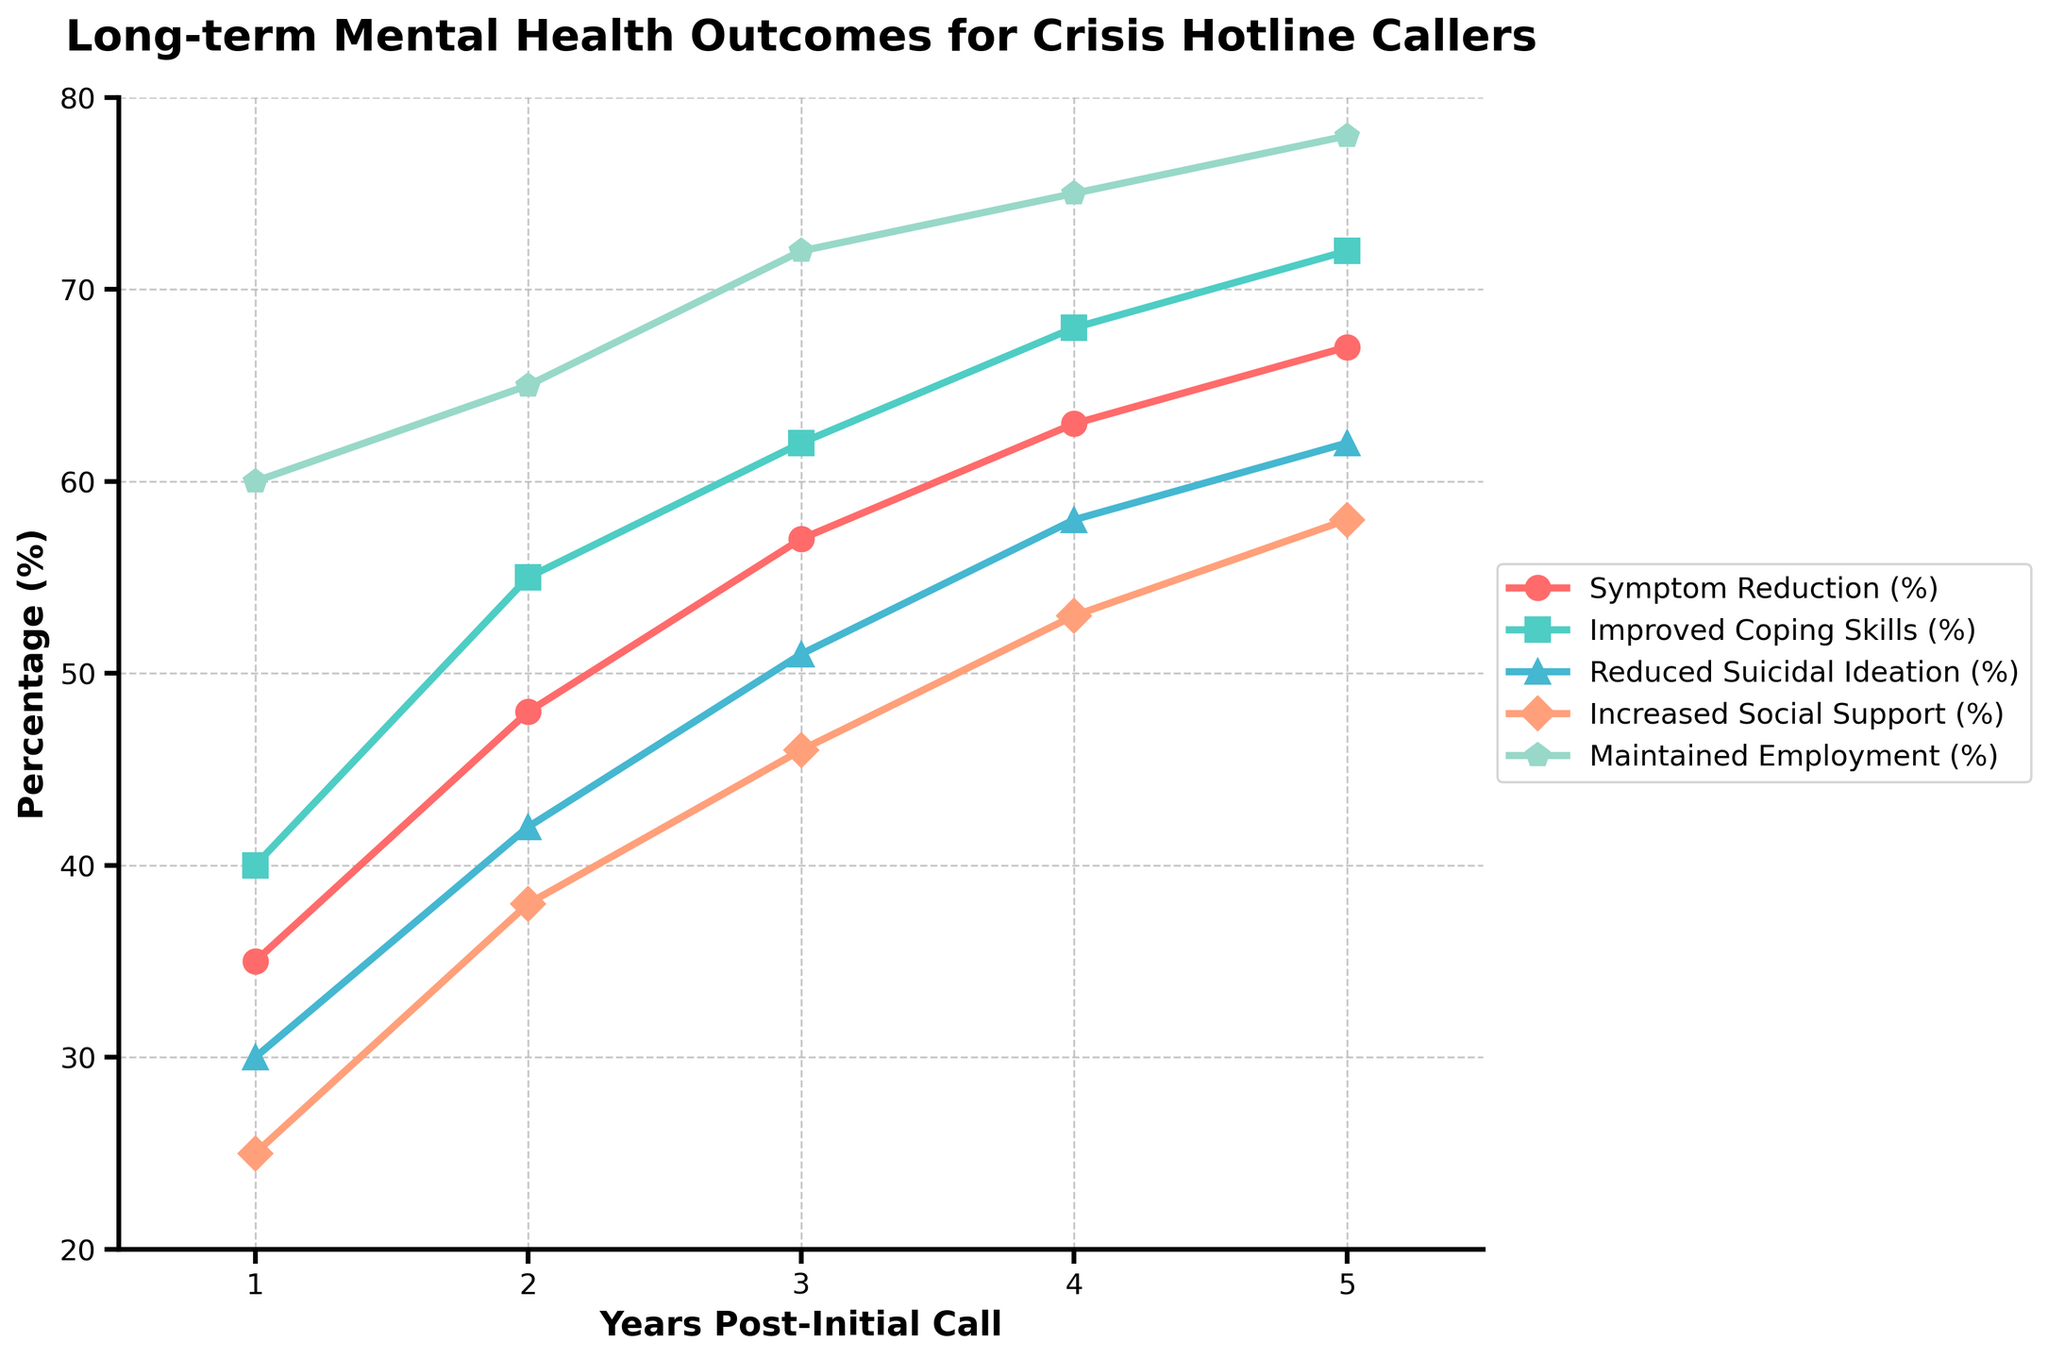What's the overall trend in symptom reduction over the 5 years? Look at the line representing symptom reduction over the 5-year span. It starts at 35% in year 1 and steadily increases each year, reaching 67% in year 5. The overall trend is clearly upward.
Answer: Upward Which metric shows the greatest percentage improvement from year 1 to year 5? Calculate the difference between year 1 and year 5 for each metric. Symptom Reduction: 67 - 35 = 32, Improved Coping Skills: 72 - 40 = 32, Reduced Suicidal Ideation: 62 - 30 = 32, Increased Social Support: 58 - 25 = 33, Maintained Employment: 78 - 60 = 18. Increased Social Support shows the greatest improvement.
Answer: Increased Social Support In year 3, how many metrics have a percentage above 50%? Examine the values for each metric in year 3. Symptom Reduction: 57%, Improved Coping Skills: 62%, Reduced Suicidal Ideation: 51%, Increased Social Support: 46%, Maintained Employment: 72%. Four metrics are above 50%.
Answer: Four What is the average percentage improvement for reduced suicidal ideation over the 5 years? Find the percentages for each year: 30%, 42%, 51%, 58%, 62%. Sum them up: 30 + 42 + 51 + 58 + 62 = 243. Divide by 5 to get the average: 243 / 5 = 48.6%.
Answer: 48.6% Which year sees the greatest increase in maintained employment compared to the previous year? Calculate the year-over-year differences: Year 2 (65 - 60 = 5), Year 3 (72 - 65 = 7), Year 4 (75 - 72 = 3), Year 5 (78 - 75 = 3). Year 3 to Year 4 sees the greatest increase.
Answer: Year 3 Between year 3 and year 5, how much does the increased social support percentage change? Find the percentages for year 3 and year 5: Year 3 (46%), Year 5 (58%). The difference is 58 - 46 = 12%.
Answer: 12% Which metric maintains the most consistent year-over-year improvement? Look at the yearly changes for each metric to determine consistency: Symptom Reduction (steady increases of around 10% per year), Improved Coping Skills (steady increases of around 11-13%), Reduced Suicidal Ideation (varies but generally increasing), Increased Social Support (steady increases of 8-13%), Maintained Employment (more consistent steady increase).
Answer: Symptom Reduction In which year do all metrics first have percentages above 40%? Review the data for each year: Year 1 (not all above 40%), Year 2 (not all above 40%), Year 3 (Symptom Reduction: 57%, Improved Coping Skills: 62%, Reduced Suicidal Ideation: 51%, Increased Social Support: 46%, Maintained Employment: 72%). All metrics reach above 40% in Year 3.
Answer: Year 3 Which metric had the highest rate of increase from year 2 to year 3? Calculate the differences from year 2 to year 3: Symptom Reduction (57 - 48 = 9), Improved Coping Skills (62 - 55 = 7), Reduced Suicidal Ideation (51 - 42 = 9), Increased Social Support (46 - 38 = 8), Maintained Employment (72 - 65 = 7). Symptom Reduction and Reduced Suicidal Ideation both increased by 9%.
Answer: Symptom Reduction and Reduced Suicidal Ideation 